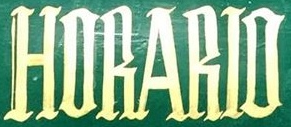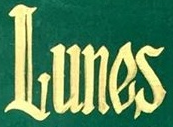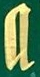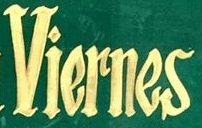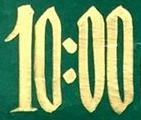What text appears in these images from left to right, separated by a semicolon? HORARIO; Lunes; a; Viernes; 10:00 